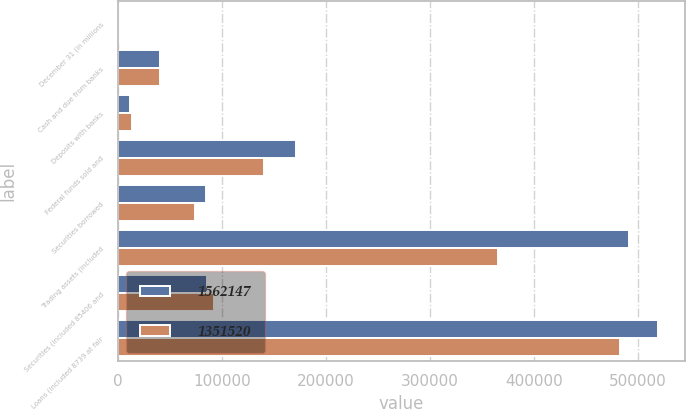<chart> <loc_0><loc_0><loc_500><loc_500><stacked_bar_chart><ecel><fcel>December 31 (in millions<fcel>Cash and due from banks<fcel>Deposits with banks<fcel>Federal funds sold and<fcel>Securities borrowed<fcel>Trading assets (included<fcel>Securities (included 85406 and<fcel>Loans (included 8739 at fair<nl><fcel>1.56215e+06<fcel>2007<fcel>40144<fcel>11466<fcel>170897<fcel>84184<fcel>491409<fcel>85450<fcel>519374<nl><fcel>1.35152e+06<fcel>2006<fcel>40412<fcel>13547<fcel>140524<fcel>73688<fcel>365738<fcel>91975<fcel>483127<nl></chart> 